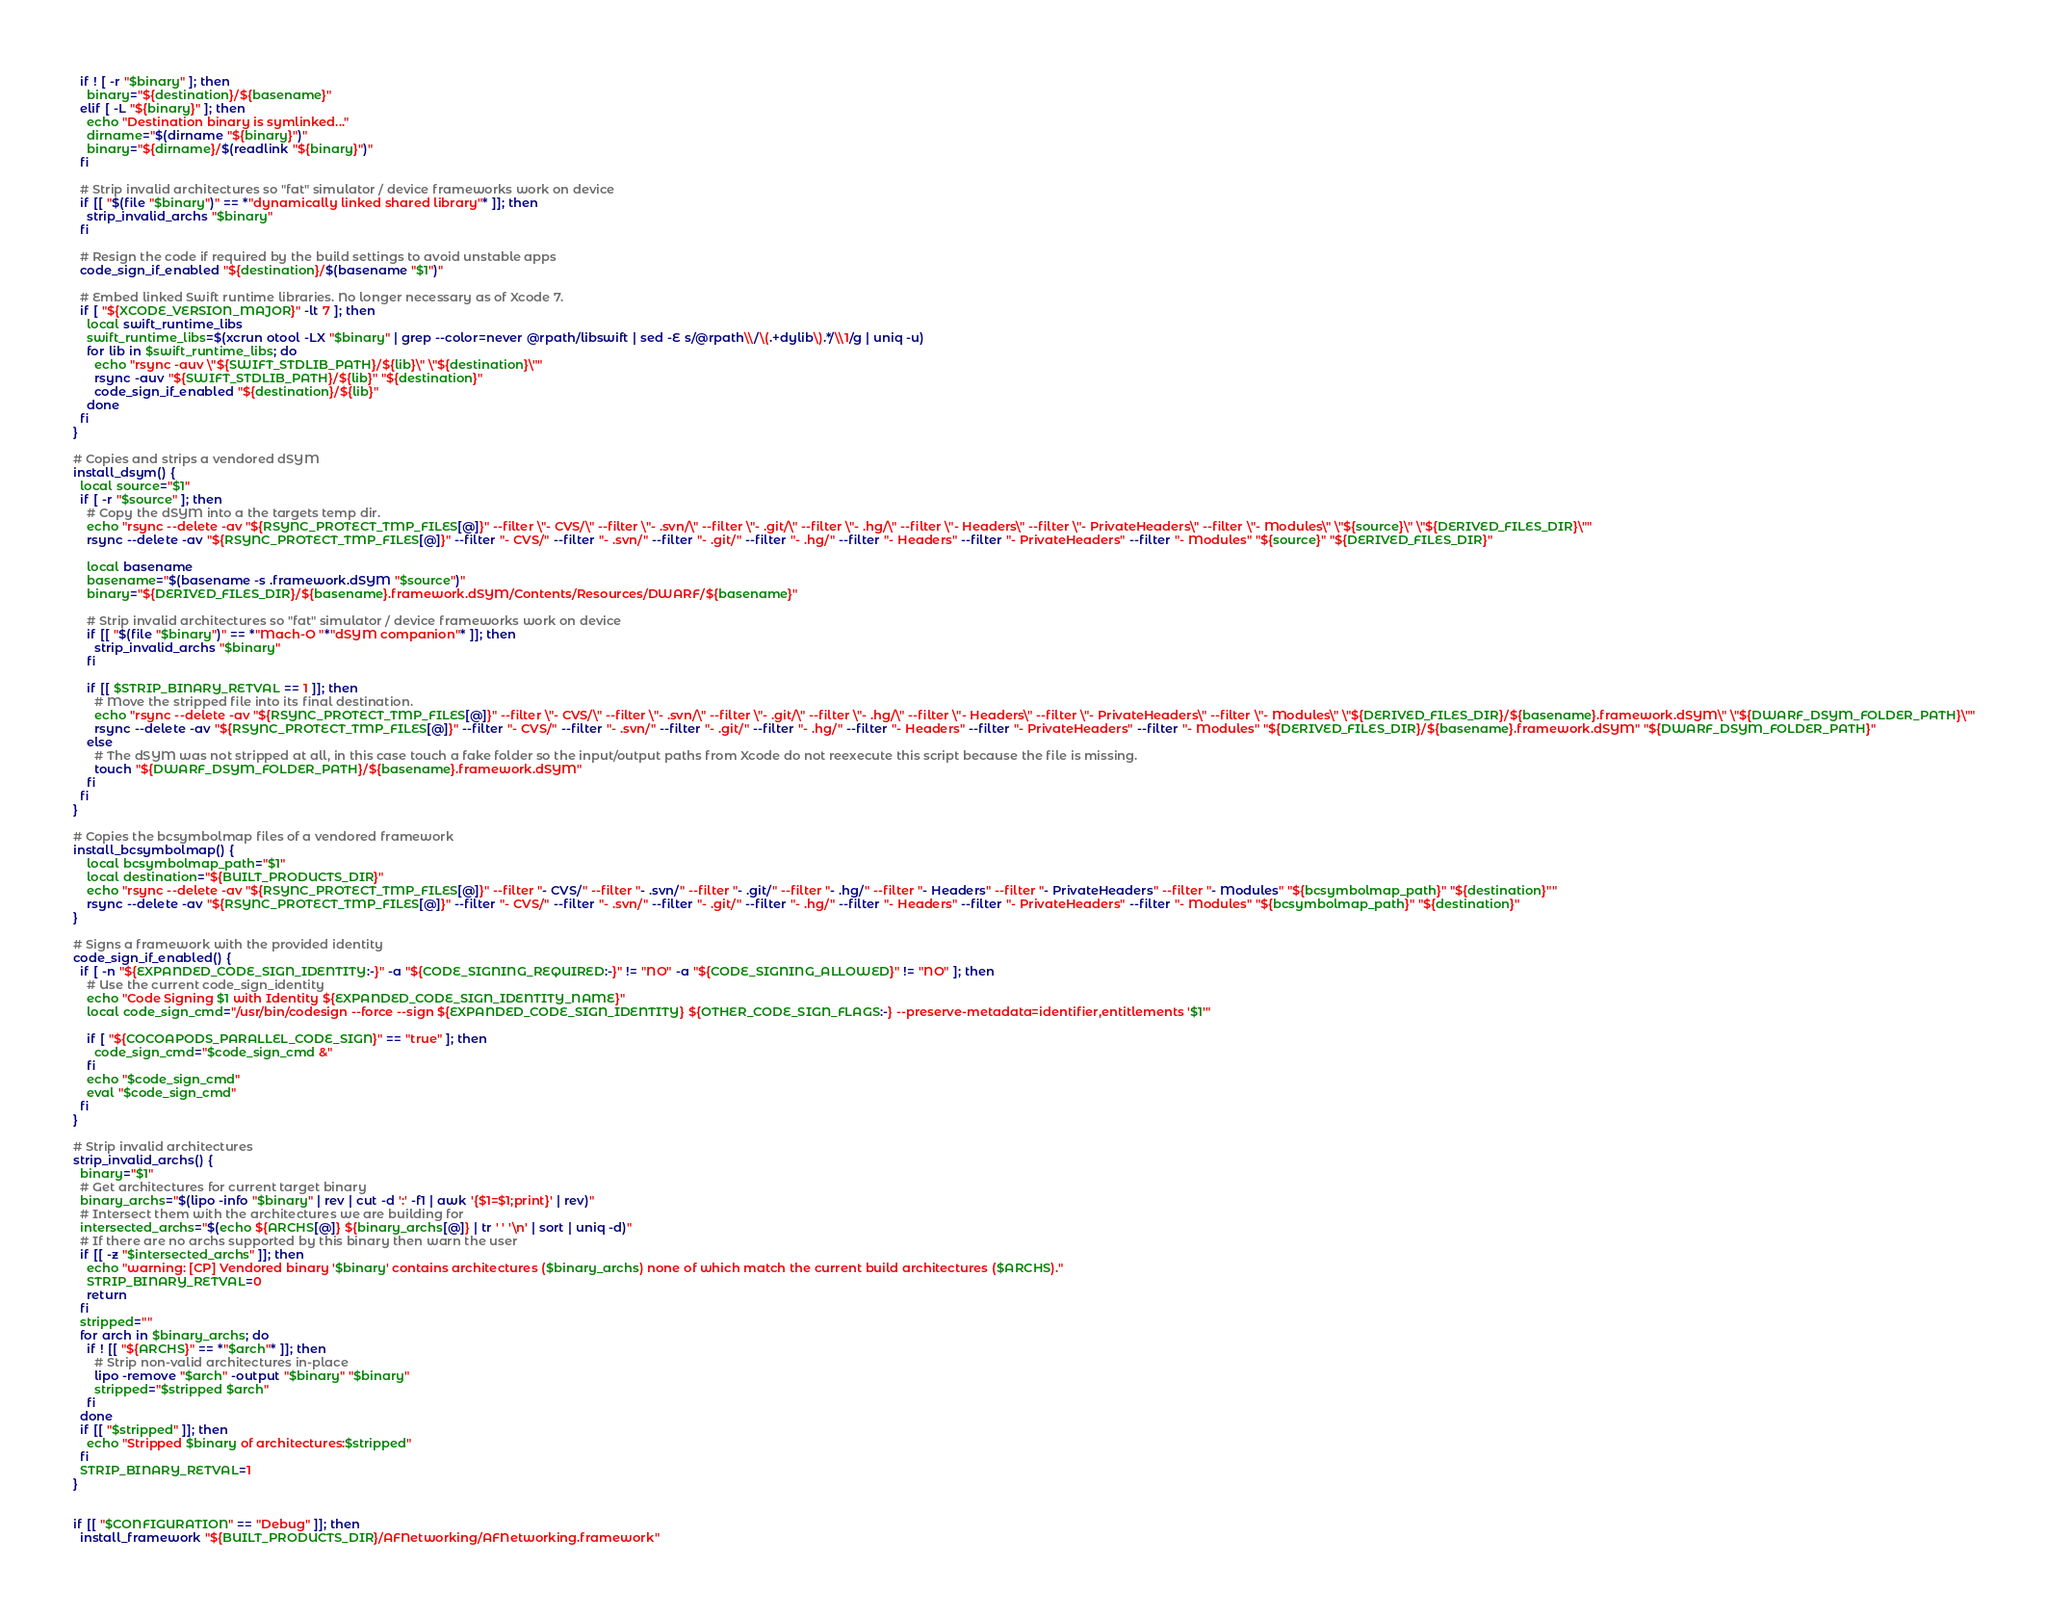Convert code to text. <code><loc_0><loc_0><loc_500><loc_500><_Bash_>  if ! [ -r "$binary" ]; then
    binary="${destination}/${basename}"
  elif [ -L "${binary}" ]; then
    echo "Destination binary is symlinked..."
    dirname="$(dirname "${binary}")"
    binary="${dirname}/$(readlink "${binary}")"
  fi

  # Strip invalid architectures so "fat" simulator / device frameworks work on device
  if [[ "$(file "$binary")" == *"dynamically linked shared library"* ]]; then
    strip_invalid_archs "$binary"
  fi

  # Resign the code if required by the build settings to avoid unstable apps
  code_sign_if_enabled "${destination}/$(basename "$1")"

  # Embed linked Swift runtime libraries. No longer necessary as of Xcode 7.
  if [ "${XCODE_VERSION_MAJOR}" -lt 7 ]; then
    local swift_runtime_libs
    swift_runtime_libs=$(xcrun otool -LX "$binary" | grep --color=never @rpath/libswift | sed -E s/@rpath\\/\(.+dylib\).*/\\1/g | uniq -u)
    for lib in $swift_runtime_libs; do
      echo "rsync -auv \"${SWIFT_STDLIB_PATH}/${lib}\" \"${destination}\""
      rsync -auv "${SWIFT_STDLIB_PATH}/${lib}" "${destination}"
      code_sign_if_enabled "${destination}/${lib}"
    done
  fi
}

# Copies and strips a vendored dSYM
install_dsym() {
  local source="$1"
  if [ -r "$source" ]; then
    # Copy the dSYM into a the targets temp dir.
    echo "rsync --delete -av "${RSYNC_PROTECT_TMP_FILES[@]}" --filter \"- CVS/\" --filter \"- .svn/\" --filter \"- .git/\" --filter \"- .hg/\" --filter \"- Headers\" --filter \"- PrivateHeaders\" --filter \"- Modules\" \"${source}\" \"${DERIVED_FILES_DIR}\""
    rsync --delete -av "${RSYNC_PROTECT_TMP_FILES[@]}" --filter "- CVS/" --filter "- .svn/" --filter "- .git/" --filter "- .hg/" --filter "- Headers" --filter "- PrivateHeaders" --filter "- Modules" "${source}" "${DERIVED_FILES_DIR}"

    local basename
    basename="$(basename -s .framework.dSYM "$source")"
    binary="${DERIVED_FILES_DIR}/${basename}.framework.dSYM/Contents/Resources/DWARF/${basename}"

    # Strip invalid architectures so "fat" simulator / device frameworks work on device
    if [[ "$(file "$binary")" == *"Mach-O "*"dSYM companion"* ]]; then
      strip_invalid_archs "$binary"
    fi

    if [[ $STRIP_BINARY_RETVAL == 1 ]]; then
      # Move the stripped file into its final destination.
      echo "rsync --delete -av "${RSYNC_PROTECT_TMP_FILES[@]}" --filter \"- CVS/\" --filter \"- .svn/\" --filter \"- .git/\" --filter \"- .hg/\" --filter \"- Headers\" --filter \"- PrivateHeaders\" --filter \"- Modules\" \"${DERIVED_FILES_DIR}/${basename}.framework.dSYM\" \"${DWARF_DSYM_FOLDER_PATH}\""
      rsync --delete -av "${RSYNC_PROTECT_TMP_FILES[@]}" --filter "- CVS/" --filter "- .svn/" --filter "- .git/" --filter "- .hg/" --filter "- Headers" --filter "- PrivateHeaders" --filter "- Modules" "${DERIVED_FILES_DIR}/${basename}.framework.dSYM" "${DWARF_DSYM_FOLDER_PATH}"
    else
      # The dSYM was not stripped at all, in this case touch a fake folder so the input/output paths from Xcode do not reexecute this script because the file is missing.
      touch "${DWARF_DSYM_FOLDER_PATH}/${basename}.framework.dSYM"
    fi
  fi
}

# Copies the bcsymbolmap files of a vendored framework
install_bcsymbolmap() {
    local bcsymbolmap_path="$1"
    local destination="${BUILT_PRODUCTS_DIR}"
    echo "rsync --delete -av "${RSYNC_PROTECT_TMP_FILES[@]}" --filter "- CVS/" --filter "- .svn/" --filter "- .git/" --filter "- .hg/" --filter "- Headers" --filter "- PrivateHeaders" --filter "- Modules" "${bcsymbolmap_path}" "${destination}""
    rsync --delete -av "${RSYNC_PROTECT_TMP_FILES[@]}" --filter "- CVS/" --filter "- .svn/" --filter "- .git/" --filter "- .hg/" --filter "- Headers" --filter "- PrivateHeaders" --filter "- Modules" "${bcsymbolmap_path}" "${destination}"
}

# Signs a framework with the provided identity
code_sign_if_enabled() {
  if [ -n "${EXPANDED_CODE_SIGN_IDENTITY:-}" -a "${CODE_SIGNING_REQUIRED:-}" != "NO" -a "${CODE_SIGNING_ALLOWED}" != "NO" ]; then
    # Use the current code_sign_identity
    echo "Code Signing $1 with Identity ${EXPANDED_CODE_SIGN_IDENTITY_NAME}"
    local code_sign_cmd="/usr/bin/codesign --force --sign ${EXPANDED_CODE_SIGN_IDENTITY} ${OTHER_CODE_SIGN_FLAGS:-} --preserve-metadata=identifier,entitlements '$1'"

    if [ "${COCOAPODS_PARALLEL_CODE_SIGN}" == "true" ]; then
      code_sign_cmd="$code_sign_cmd &"
    fi
    echo "$code_sign_cmd"
    eval "$code_sign_cmd"
  fi
}

# Strip invalid architectures
strip_invalid_archs() {
  binary="$1"
  # Get architectures for current target binary
  binary_archs="$(lipo -info "$binary" | rev | cut -d ':' -f1 | awk '{$1=$1;print}' | rev)"
  # Intersect them with the architectures we are building for
  intersected_archs="$(echo ${ARCHS[@]} ${binary_archs[@]} | tr ' ' '\n' | sort | uniq -d)"
  # If there are no archs supported by this binary then warn the user
  if [[ -z "$intersected_archs" ]]; then
    echo "warning: [CP] Vendored binary '$binary' contains architectures ($binary_archs) none of which match the current build architectures ($ARCHS)."
    STRIP_BINARY_RETVAL=0
    return
  fi
  stripped=""
  for arch in $binary_archs; do
    if ! [[ "${ARCHS}" == *"$arch"* ]]; then
      # Strip non-valid architectures in-place
      lipo -remove "$arch" -output "$binary" "$binary"
      stripped="$stripped $arch"
    fi
  done
  if [[ "$stripped" ]]; then
    echo "Stripped $binary of architectures:$stripped"
  fi
  STRIP_BINARY_RETVAL=1
}


if [[ "$CONFIGURATION" == "Debug" ]]; then
  install_framework "${BUILT_PRODUCTS_DIR}/AFNetworking/AFNetworking.framework"</code> 